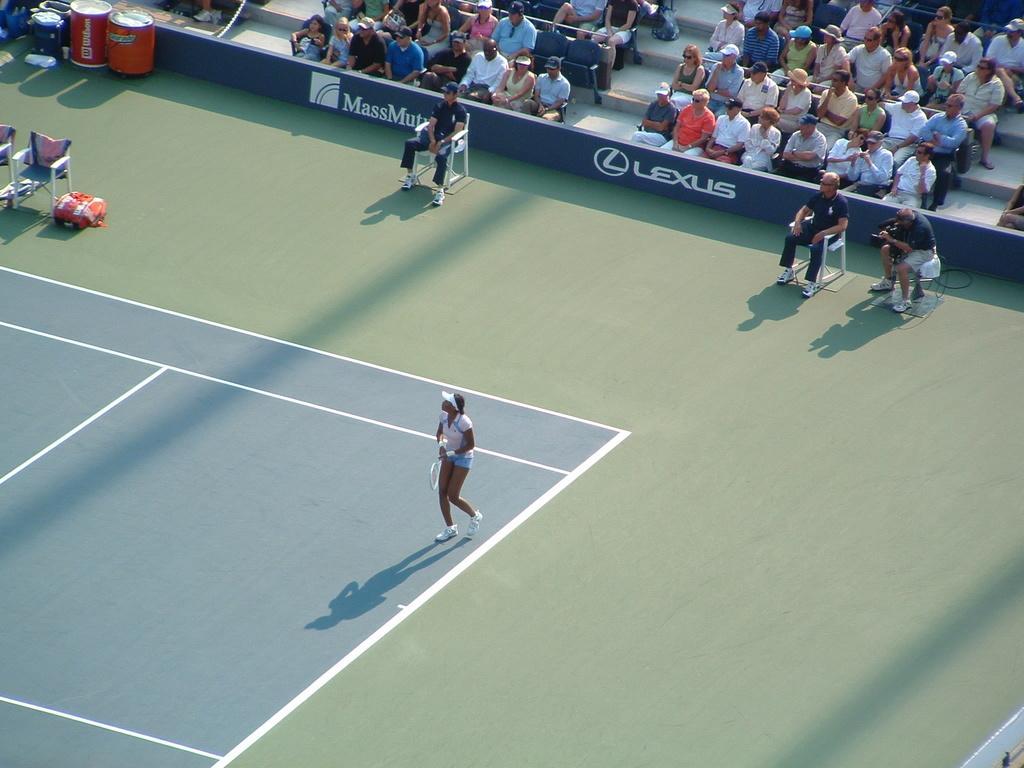Please provide a concise description of this image. There is one person standing in the ground and holding a bat as we can see at the bottom of this image. There are some persons sitting on a white color chairs inside to this ground. There are some persons sitting in a seating area at the top of this image. There are some objects and chairs kept at the top left corner of this image. 